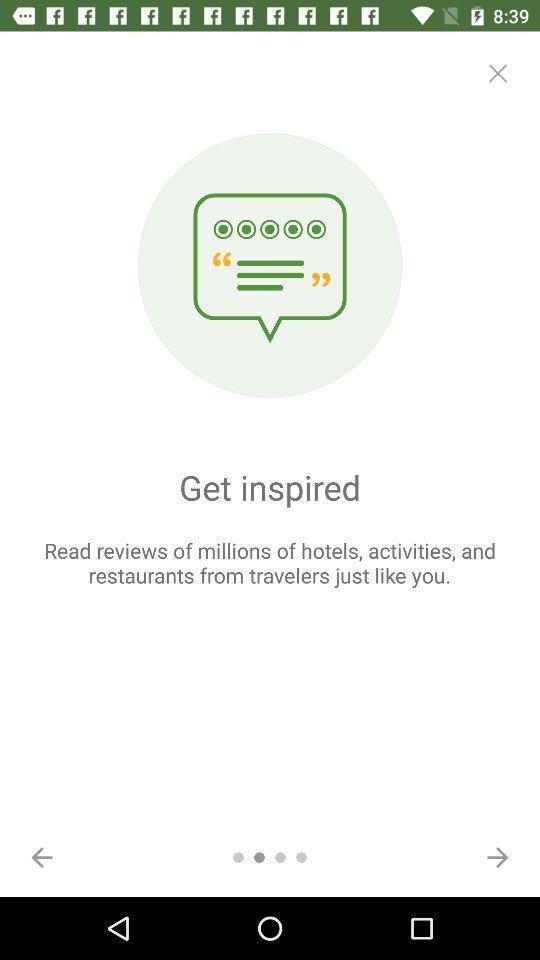Tell me what you see in this picture. Welcome page of a travelling application. 